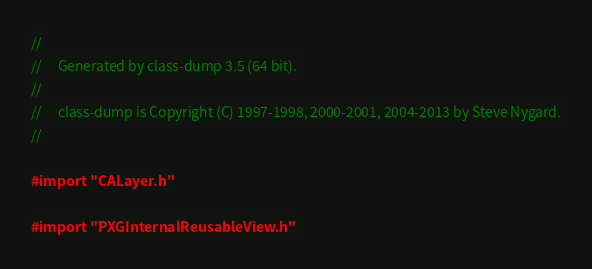<code> <loc_0><loc_0><loc_500><loc_500><_C_>//
//     Generated by class-dump 3.5 (64 bit).
//
//     class-dump is Copyright (C) 1997-1998, 2000-2001, 2004-2013 by Steve Nygard.
//

#import "CALayer.h"

#import "PXGInternalReusableView.h"
</code> 